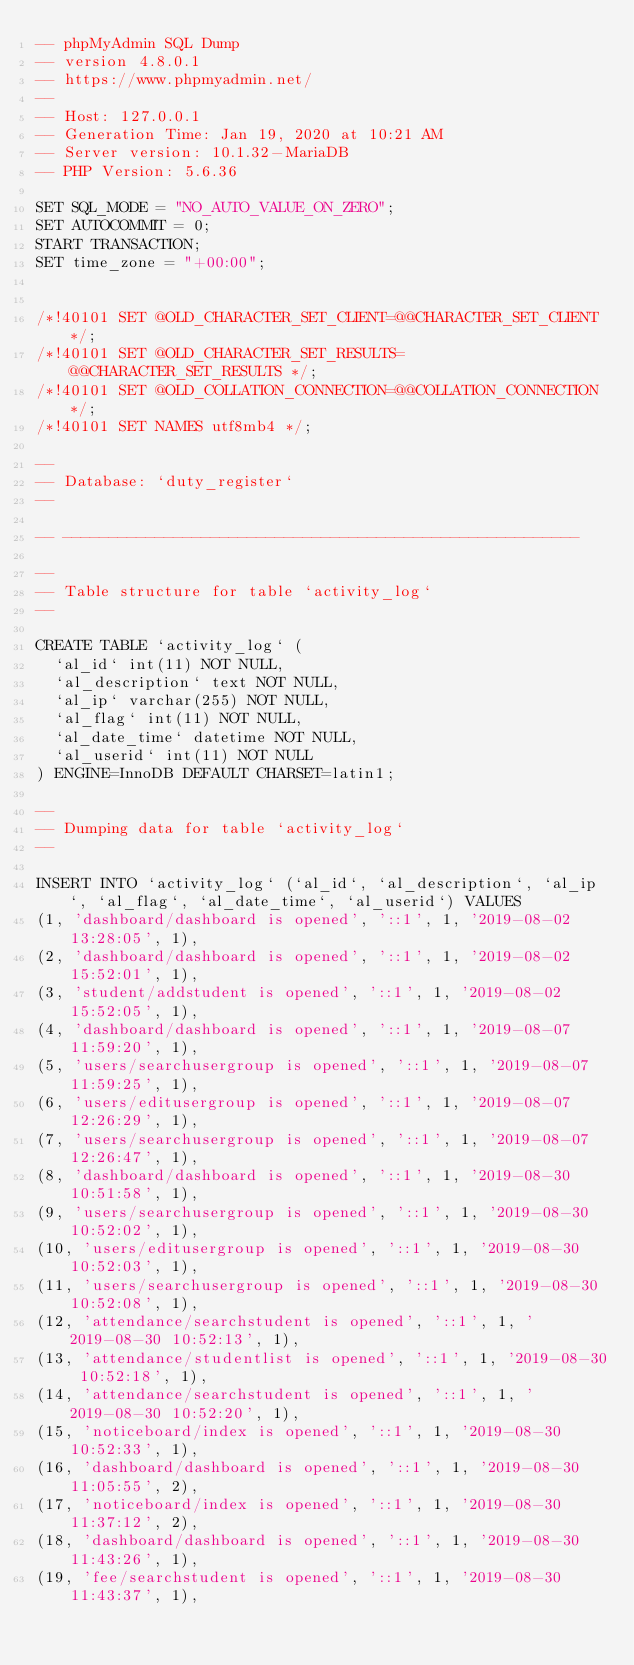Convert code to text. <code><loc_0><loc_0><loc_500><loc_500><_SQL_>-- phpMyAdmin SQL Dump
-- version 4.8.0.1
-- https://www.phpmyadmin.net/
--
-- Host: 127.0.0.1
-- Generation Time: Jan 19, 2020 at 10:21 AM
-- Server version: 10.1.32-MariaDB
-- PHP Version: 5.6.36

SET SQL_MODE = "NO_AUTO_VALUE_ON_ZERO";
SET AUTOCOMMIT = 0;
START TRANSACTION;
SET time_zone = "+00:00";


/*!40101 SET @OLD_CHARACTER_SET_CLIENT=@@CHARACTER_SET_CLIENT */;
/*!40101 SET @OLD_CHARACTER_SET_RESULTS=@@CHARACTER_SET_RESULTS */;
/*!40101 SET @OLD_COLLATION_CONNECTION=@@COLLATION_CONNECTION */;
/*!40101 SET NAMES utf8mb4 */;

--
-- Database: `duty_register`
--

-- --------------------------------------------------------

--
-- Table structure for table `activity_log`
--

CREATE TABLE `activity_log` (
  `al_id` int(11) NOT NULL,
  `al_description` text NOT NULL,
  `al_ip` varchar(255) NOT NULL,
  `al_flag` int(11) NOT NULL,
  `al_date_time` datetime NOT NULL,
  `al_userid` int(11) NOT NULL
) ENGINE=InnoDB DEFAULT CHARSET=latin1;

--
-- Dumping data for table `activity_log`
--

INSERT INTO `activity_log` (`al_id`, `al_description`, `al_ip`, `al_flag`, `al_date_time`, `al_userid`) VALUES
(1, 'dashboard/dashboard is opened', '::1', 1, '2019-08-02 13:28:05', 1),
(2, 'dashboard/dashboard is opened', '::1', 1, '2019-08-02 15:52:01', 1),
(3, 'student/addstudent is opened', '::1', 1, '2019-08-02 15:52:05', 1),
(4, 'dashboard/dashboard is opened', '::1', 1, '2019-08-07 11:59:20', 1),
(5, 'users/searchusergroup is opened', '::1', 1, '2019-08-07 11:59:25', 1),
(6, 'users/editusergroup is opened', '::1', 1, '2019-08-07 12:26:29', 1),
(7, 'users/searchusergroup is opened', '::1', 1, '2019-08-07 12:26:47', 1),
(8, 'dashboard/dashboard is opened', '::1', 1, '2019-08-30 10:51:58', 1),
(9, 'users/searchusergroup is opened', '::1', 1, '2019-08-30 10:52:02', 1),
(10, 'users/editusergroup is opened', '::1', 1, '2019-08-30 10:52:03', 1),
(11, 'users/searchusergroup is opened', '::1', 1, '2019-08-30 10:52:08', 1),
(12, 'attendance/searchstudent is opened', '::1', 1, '2019-08-30 10:52:13', 1),
(13, 'attendance/studentlist is opened', '::1', 1, '2019-08-30 10:52:18', 1),
(14, 'attendance/searchstudent is opened', '::1', 1, '2019-08-30 10:52:20', 1),
(15, 'noticeboard/index is opened', '::1', 1, '2019-08-30 10:52:33', 1),
(16, 'dashboard/dashboard is opened', '::1', 1, '2019-08-30 11:05:55', 2),
(17, 'noticeboard/index is opened', '::1', 1, '2019-08-30 11:37:12', 2),
(18, 'dashboard/dashboard is opened', '::1', 1, '2019-08-30 11:43:26', 1),
(19, 'fee/searchstudent is opened', '::1', 1, '2019-08-30 11:43:37', 1),</code> 